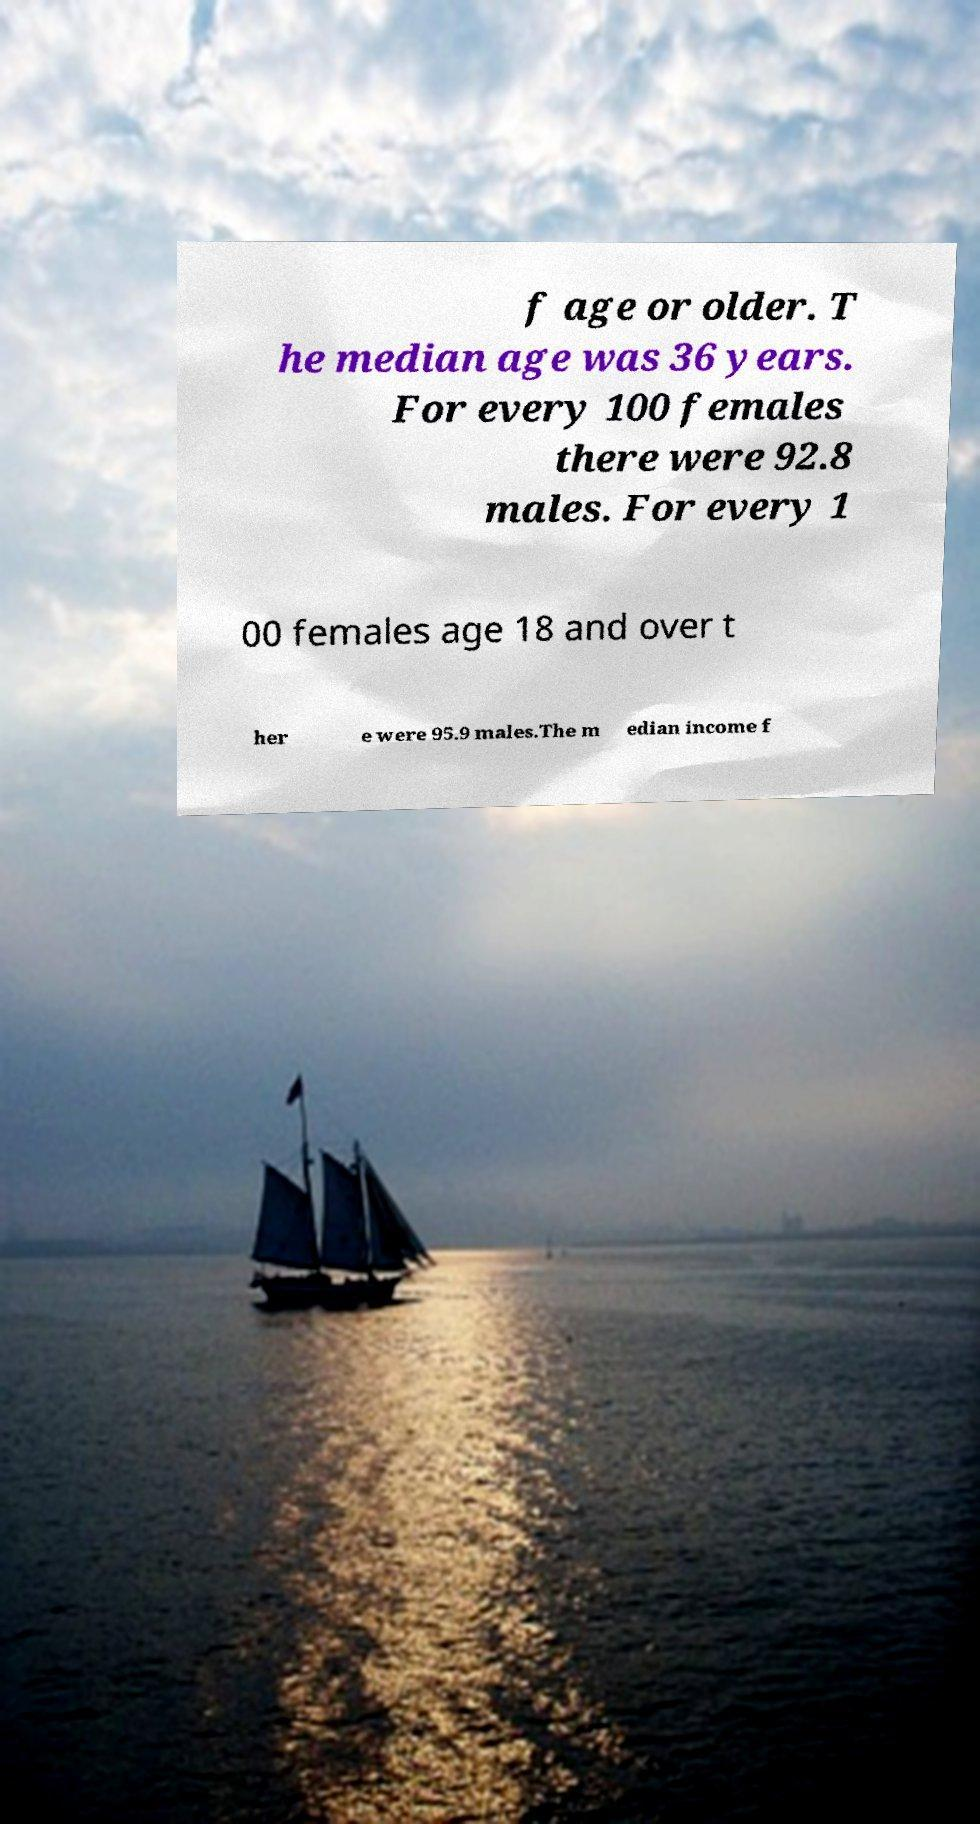I need the written content from this picture converted into text. Can you do that? f age or older. T he median age was 36 years. For every 100 females there were 92.8 males. For every 1 00 females age 18 and over t her e were 95.9 males.The m edian income f 